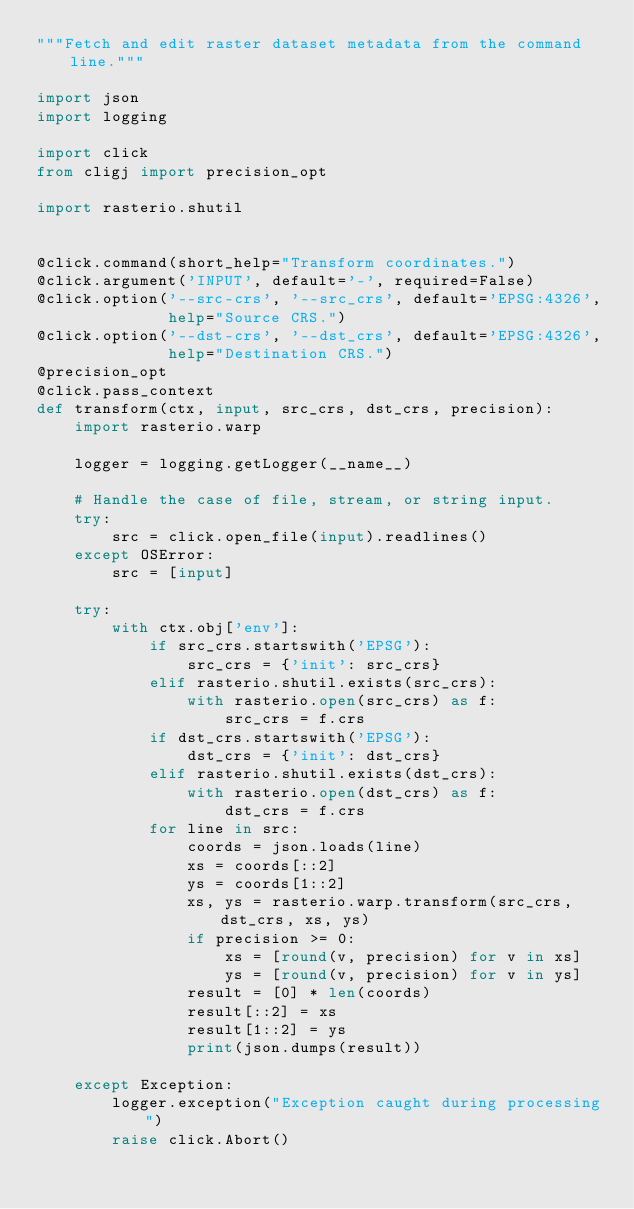Convert code to text. <code><loc_0><loc_0><loc_500><loc_500><_Python_>"""Fetch and edit raster dataset metadata from the command line."""

import json
import logging

import click
from cligj import precision_opt

import rasterio.shutil


@click.command(short_help="Transform coordinates.")
@click.argument('INPUT', default='-', required=False)
@click.option('--src-crs', '--src_crs', default='EPSG:4326',
              help="Source CRS.")
@click.option('--dst-crs', '--dst_crs', default='EPSG:4326',
              help="Destination CRS.")
@precision_opt
@click.pass_context
def transform(ctx, input, src_crs, dst_crs, precision):
    import rasterio.warp

    logger = logging.getLogger(__name__)

    # Handle the case of file, stream, or string input.
    try:
        src = click.open_file(input).readlines()
    except OSError:
        src = [input]

    try:
        with ctx.obj['env']:
            if src_crs.startswith('EPSG'):
                src_crs = {'init': src_crs}
            elif rasterio.shutil.exists(src_crs):
                with rasterio.open(src_crs) as f:
                    src_crs = f.crs
            if dst_crs.startswith('EPSG'):
                dst_crs = {'init': dst_crs}
            elif rasterio.shutil.exists(dst_crs):
                with rasterio.open(dst_crs) as f:
                    dst_crs = f.crs
            for line in src:
                coords = json.loads(line)
                xs = coords[::2]
                ys = coords[1::2]
                xs, ys = rasterio.warp.transform(src_crs, dst_crs, xs, ys)
                if precision >= 0:
                    xs = [round(v, precision) for v in xs]
                    ys = [round(v, precision) for v in ys]
                result = [0] * len(coords)
                result[::2] = xs
                result[1::2] = ys
                print(json.dumps(result))

    except Exception:
        logger.exception("Exception caught during processing")
        raise click.Abort()
</code> 